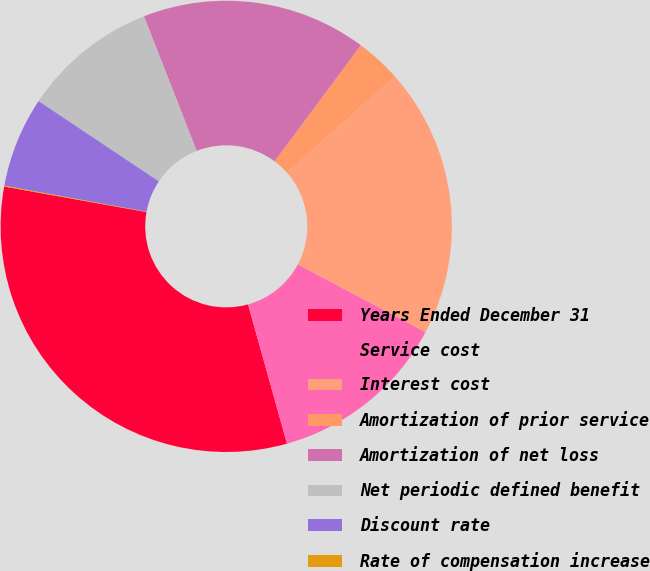Convert chart to OTSL. <chart><loc_0><loc_0><loc_500><loc_500><pie_chart><fcel>Years Ended December 31<fcel>Service cost<fcel>Interest cost<fcel>Amortization of prior service<fcel>Amortization of net loss<fcel>Net periodic defined benefit<fcel>Discount rate<fcel>Rate of compensation increase<nl><fcel>32.16%<fcel>12.9%<fcel>19.32%<fcel>3.27%<fcel>16.11%<fcel>9.69%<fcel>6.48%<fcel>0.06%<nl></chart> 